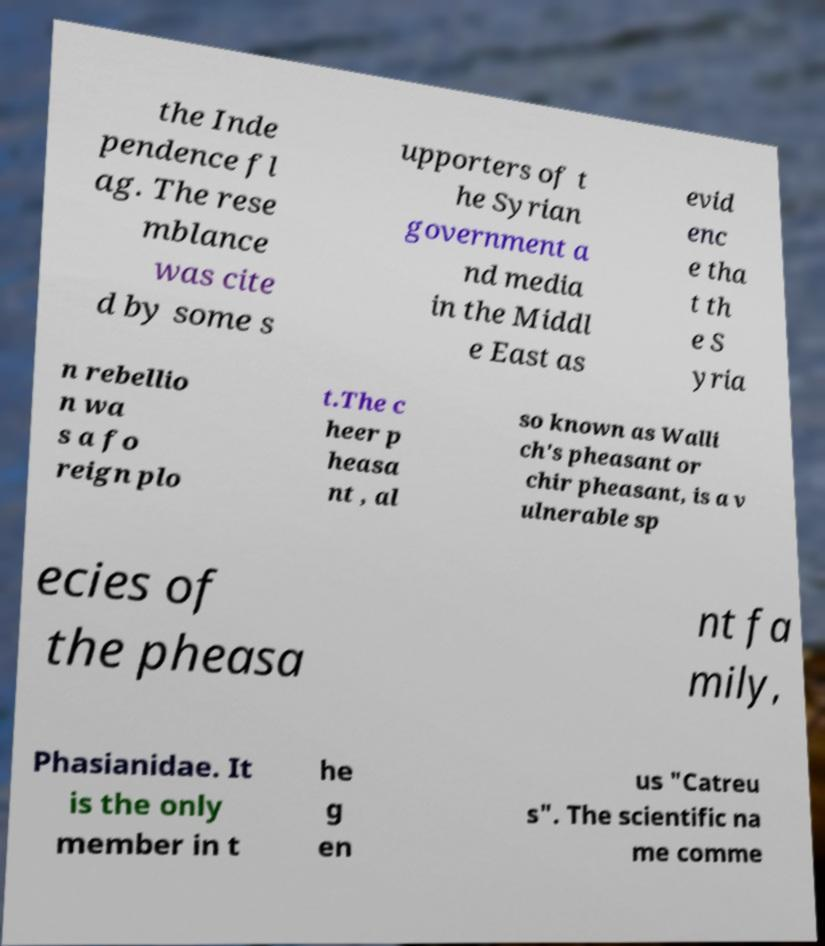What messages or text are displayed in this image? I need them in a readable, typed format. the Inde pendence fl ag. The rese mblance was cite d by some s upporters of t he Syrian government a nd media in the Middl e East as evid enc e tha t th e S yria n rebellio n wa s a fo reign plo t.The c heer p heasa nt , al so known as Walli ch's pheasant or chir pheasant, is a v ulnerable sp ecies of the pheasa nt fa mily, Phasianidae. It is the only member in t he g en us "Catreu s". The scientific na me comme 